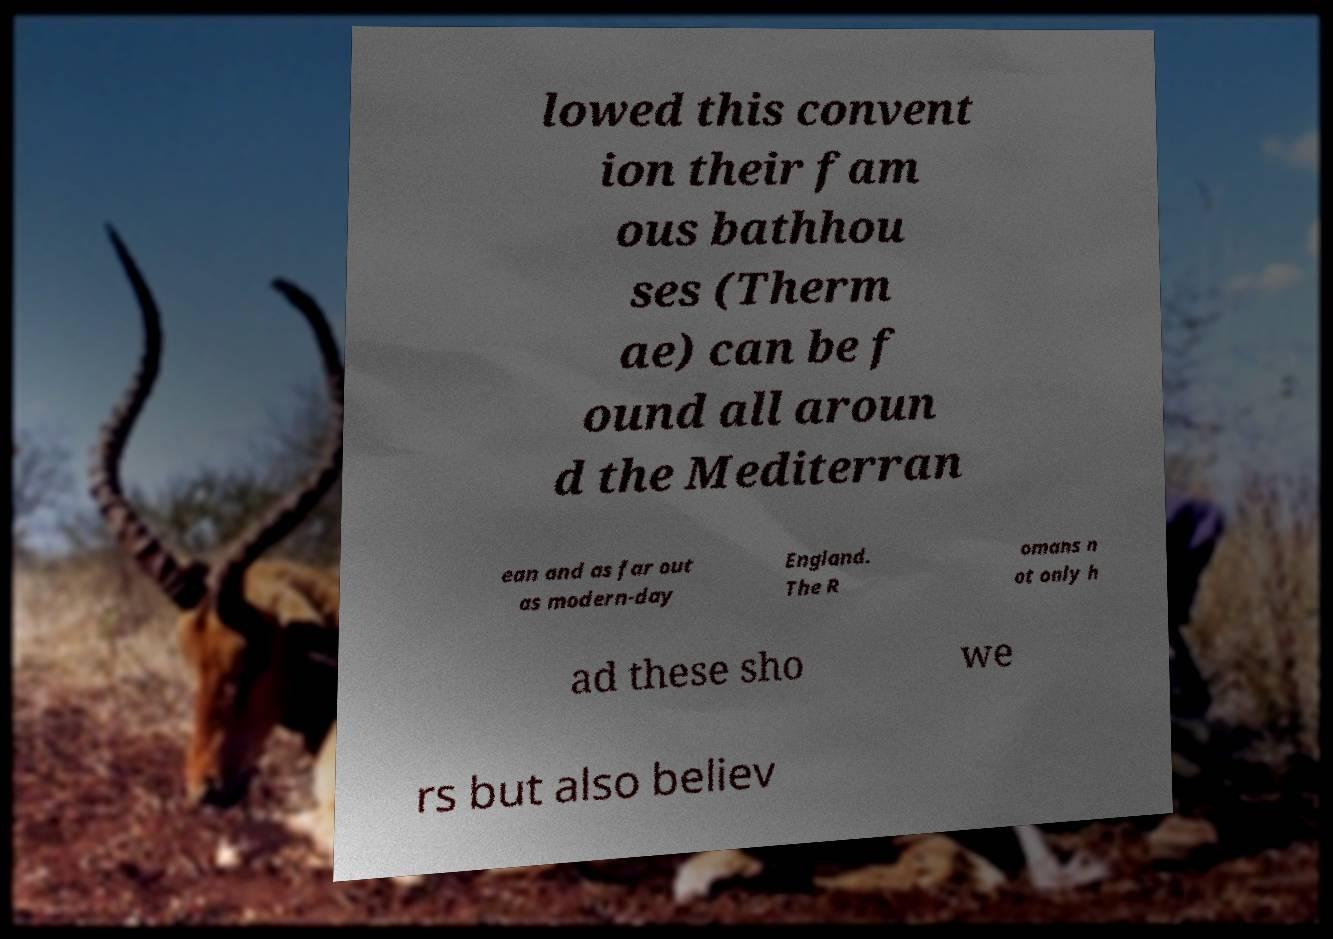What messages or text are displayed in this image? I need them in a readable, typed format. lowed this convent ion their fam ous bathhou ses (Therm ae) can be f ound all aroun d the Mediterran ean and as far out as modern-day England. The R omans n ot only h ad these sho we rs but also believ 